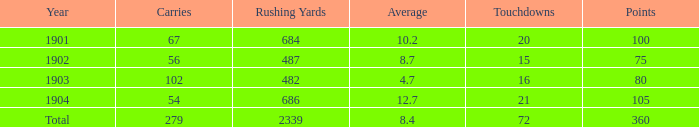What is the sum of carries associated with 80 points and fewer than 16 touchdowns? None. 